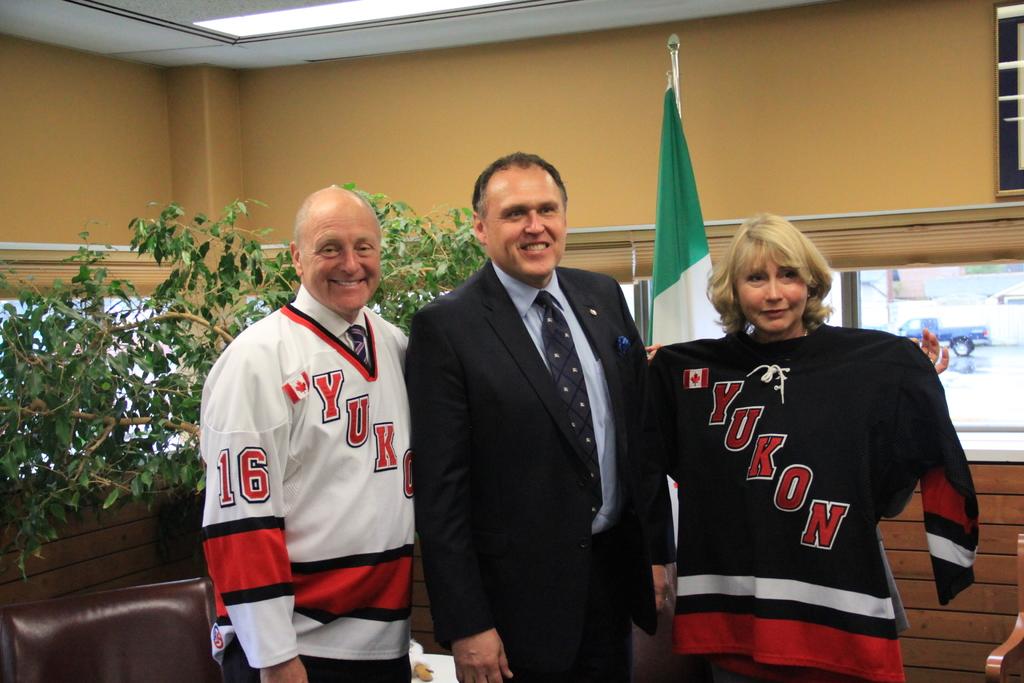What player number is represented on the man's shirt who is standing to the left?
Your answer should be very brief. 16. What is the team name of the jerseys?
Your answer should be compact. Yukon. 